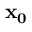Convert formula to latex. <formula><loc_0><loc_0><loc_500><loc_500>{ x _ { 0 } }</formula> 